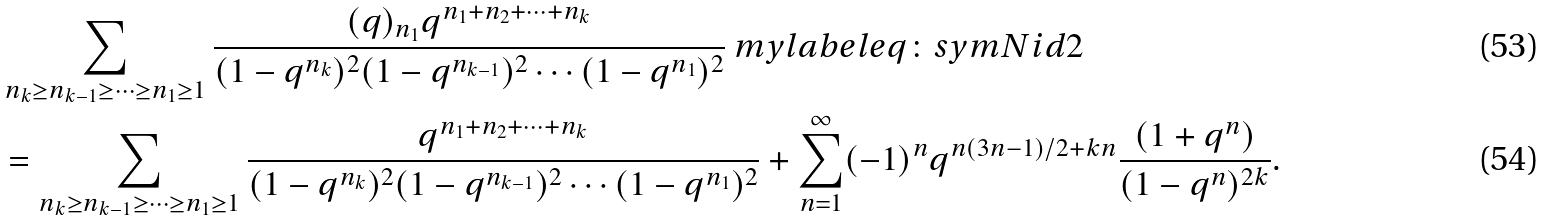Convert formula to latex. <formula><loc_0><loc_0><loc_500><loc_500>& \sum _ { n _ { k } \geq n _ { k - 1 } \geq \cdots \geq n _ { 1 } \geq 1 } \frac { ( q ) _ { n _ { 1 } } q ^ { n _ { 1 } + n _ { 2 } + \cdots + n _ { k } } } { ( 1 - q ^ { n _ { k } } ) ^ { 2 } ( 1 - q ^ { n _ { k - 1 } } ) ^ { 2 } \cdots ( 1 - q ^ { n _ { 1 } } ) ^ { 2 } } \ m y l a b e l { e q \colon s y m N i d 2 } \\ & = \sum _ { n _ { k } \geq n _ { k - 1 } \geq \cdots \geq n _ { 1 } \geq 1 } \frac { q ^ { n _ { 1 } + n _ { 2 } + \cdots + n _ { k } } } { ( 1 - q ^ { n _ { k } } ) ^ { 2 } ( 1 - q ^ { n _ { k - 1 } } ) ^ { 2 } \cdots ( 1 - q ^ { n _ { 1 } } ) ^ { 2 } } + \sum _ { n = 1 } ^ { \infty } ( - 1 ) ^ { n } q ^ { n ( 3 n - 1 ) / 2 + k n } \frac { ( 1 + q ^ { n } ) } { ( 1 - q ^ { n } ) ^ { 2 k } } .</formula> 